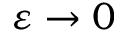<formula> <loc_0><loc_0><loc_500><loc_500>\varepsilon \rightarrow 0</formula> 